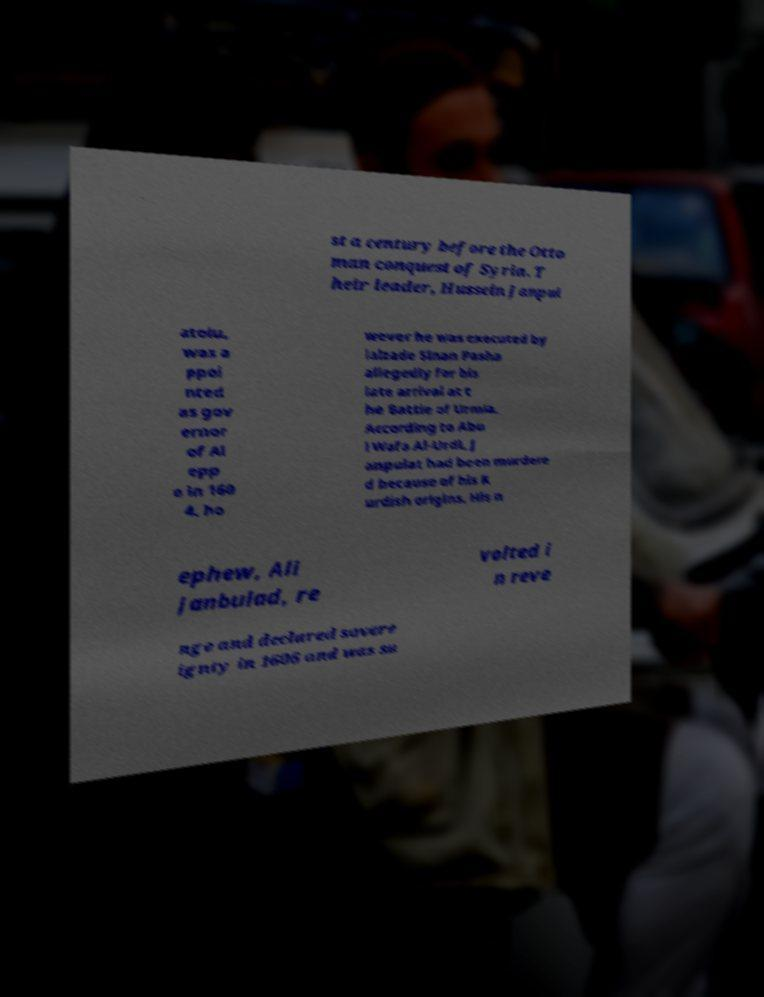Please read and relay the text visible in this image. What does it say? st a century before the Otto man conquest of Syria. T heir leader, Hussein Janpul atolu, was a ppoi nted as gov ernor of Al epp o in 160 4, ho wever he was executed by ialzade Sinan Pasha allegedly for his late arrival at t he Battle of Urmia. According to Abu l Wafa Al-Urdi, J anpulat had been murdere d because of his K urdish origins. His n ephew, Ali Janbulad, re volted i n reve nge and declared sovere ignty in 1606 and was su 